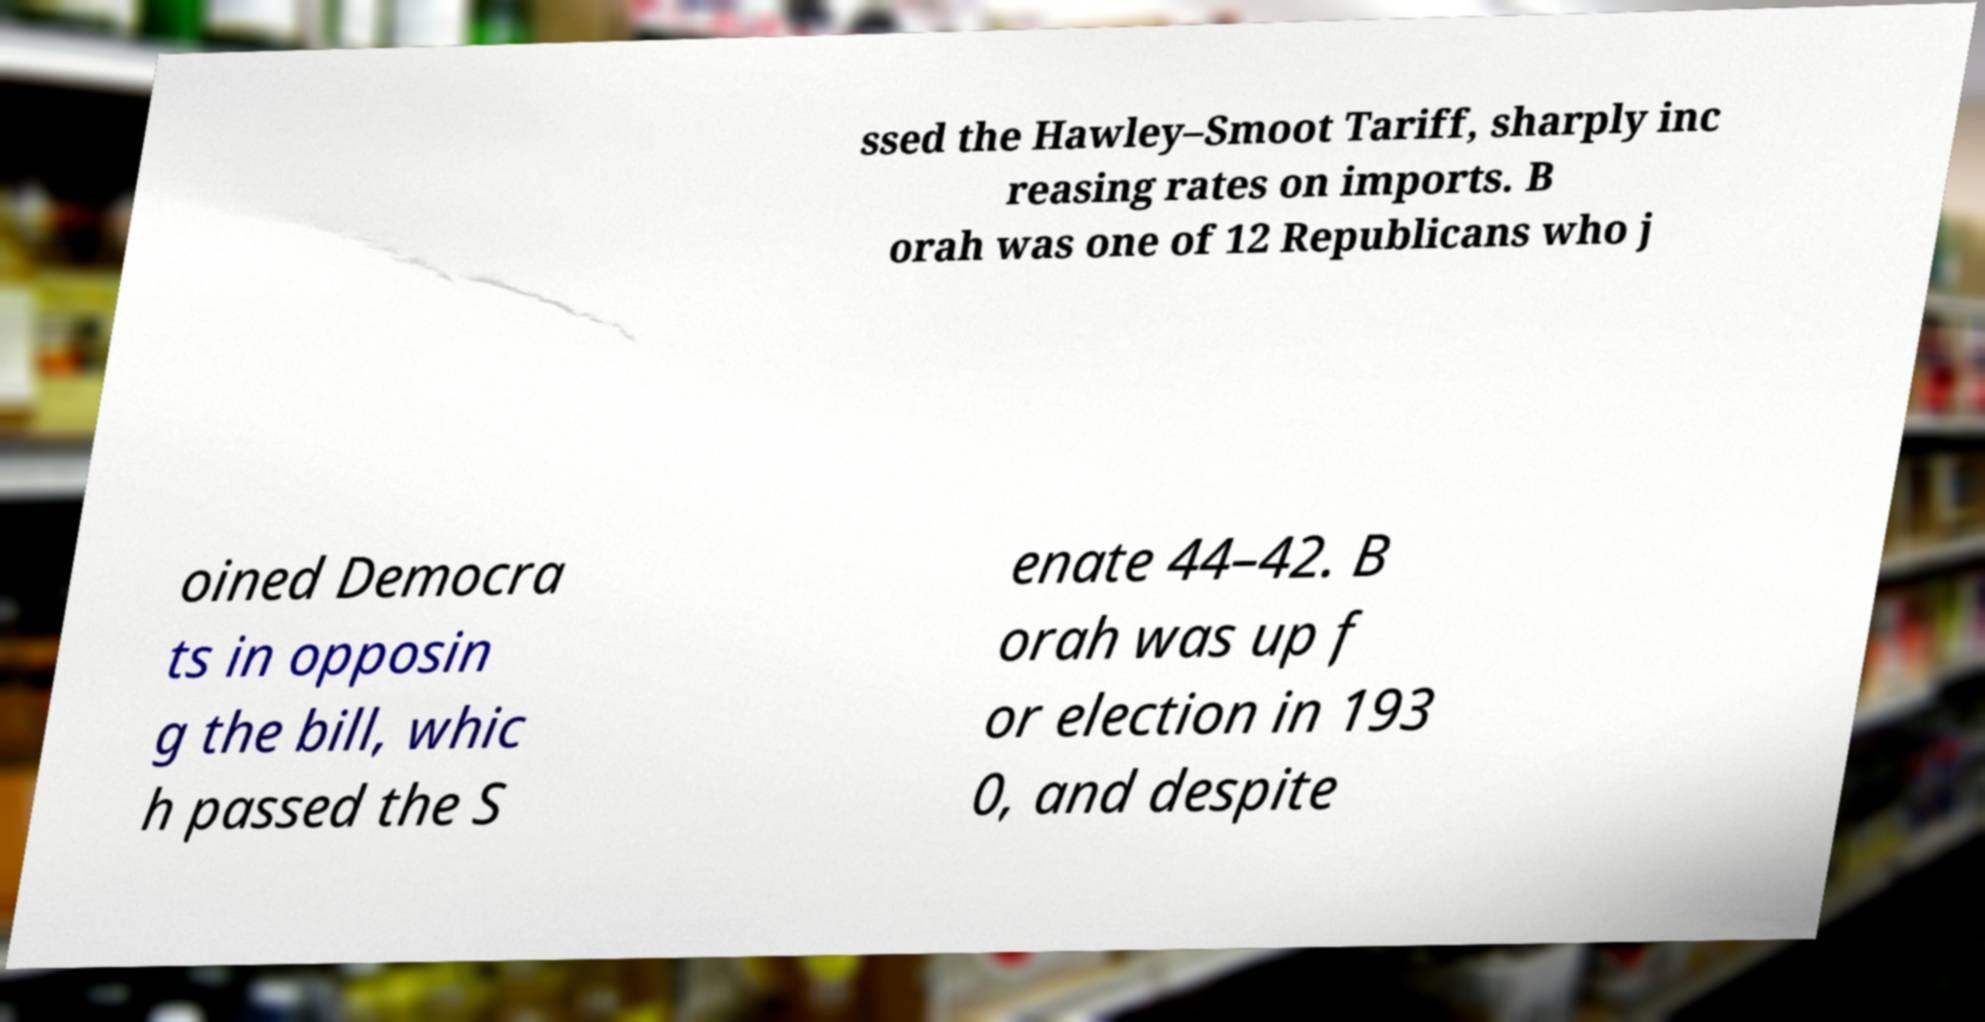There's text embedded in this image that I need extracted. Can you transcribe it verbatim? ssed the Hawley–Smoot Tariff, sharply inc reasing rates on imports. B orah was one of 12 Republicans who j oined Democra ts in opposin g the bill, whic h passed the S enate 44–42. B orah was up f or election in 193 0, and despite 